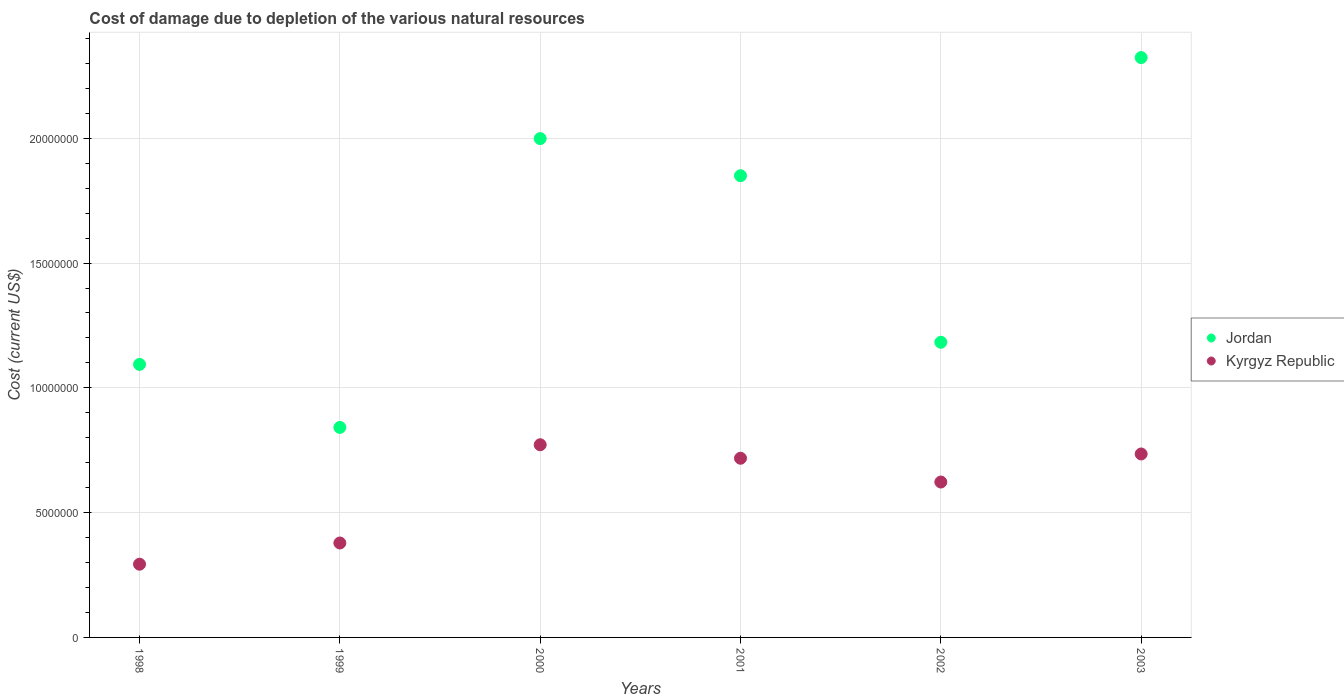How many different coloured dotlines are there?
Give a very brief answer. 2. What is the cost of damage caused due to the depletion of various natural resources in Jordan in 1998?
Give a very brief answer. 1.09e+07. Across all years, what is the maximum cost of damage caused due to the depletion of various natural resources in Kyrgyz Republic?
Ensure brevity in your answer.  7.72e+06. Across all years, what is the minimum cost of damage caused due to the depletion of various natural resources in Jordan?
Provide a succinct answer. 8.41e+06. In which year was the cost of damage caused due to the depletion of various natural resources in Kyrgyz Republic maximum?
Offer a terse response. 2000. What is the total cost of damage caused due to the depletion of various natural resources in Jordan in the graph?
Provide a succinct answer. 9.29e+07. What is the difference between the cost of damage caused due to the depletion of various natural resources in Jordan in 1998 and that in 2002?
Provide a short and direct response. -8.87e+05. What is the difference between the cost of damage caused due to the depletion of various natural resources in Jordan in 2002 and the cost of damage caused due to the depletion of various natural resources in Kyrgyz Republic in 1999?
Give a very brief answer. 8.04e+06. What is the average cost of damage caused due to the depletion of various natural resources in Kyrgyz Republic per year?
Your answer should be compact. 5.87e+06. In the year 2000, what is the difference between the cost of damage caused due to the depletion of various natural resources in Jordan and cost of damage caused due to the depletion of various natural resources in Kyrgyz Republic?
Your response must be concise. 1.23e+07. What is the ratio of the cost of damage caused due to the depletion of various natural resources in Kyrgyz Republic in 1999 to that in 2001?
Offer a very short reply. 0.53. Is the cost of damage caused due to the depletion of various natural resources in Kyrgyz Republic in 2000 less than that in 2003?
Provide a succinct answer. No. What is the difference between the highest and the second highest cost of damage caused due to the depletion of various natural resources in Jordan?
Make the answer very short. 3.25e+06. What is the difference between the highest and the lowest cost of damage caused due to the depletion of various natural resources in Jordan?
Keep it short and to the point. 1.48e+07. In how many years, is the cost of damage caused due to the depletion of various natural resources in Kyrgyz Republic greater than the average cost of damage caused due to the depletion of various natural resources in Kyrgyz Republic taken over all years?
Offer a terse response. 4. Is the sum of the cost of damage caused due to the depletion of various natural resources in Jordan in 2000 and 2003 greater than the maximum cost of damage caused due to the depletion of various natural resources in Kyrgyz Republic across all years?
Provide a short and direct response. Yes. Does the cost of damage caused due to the depletion of various natural resources in Kyrgyz Republic monotonically increase over the years?
Make the answer very short. No. Is the cost of damage caused due to the depletion of various natural resources in Jordan strictly less than the cost of damage caused due to the depletion of various natural resources in Kyrgyz Republic over the years?
Ensure brevity in your answer.  No. How many dotlines are there?
Make the answer very short. 2. How many years are there in the graph?
Provide a succinct answer. 6. What is the difference between two consecutive major ticks on the Y-axis?
Make the answer very short. 5.00e+06. Are the values on the major ticks of Y-axis written in scientific E-notation?
Offer a terse response. No. How are the legend labels stacked?
Provide a short and direct response. Vertical. What is the title of the graph?
Provide a short and direct response. Cost of damage due to depletion of the various natural resources. What is the label or title of the X-axis?
Offer a terse response. Years. What is the label or title of the Y-axis?
Your response must be concise. Cost (current US$). What is the Cost (current US$) in Jordan in 1998?
Your answer should be very brief. 1.09e+07. What is the Cost (current US$) in Kyrgyz Republic in 1998?
Your answer should be very brief. 2.93e+06. What is the Cost (current US$) of Jordan in 1999?
Keep it short and to the point. 8.41e+06. What is the Cost (current US$) of Kyrgyz Republic in 1999?
Your answer should be compact. 3.78e+06. What is the Cost (current US$) in Jordan in 2000?
Offer a terse response. 2.00e+07. What is the Cost (current US$) in Kyrgyz Republic in 2000?
Your answer should be compact. 7.72e+06. What is the Cost (current US$) in Jordan in 2001?
Offer a terse response. 1.85e+07. What is the Cost (current US$) of Kyrgyz Republic in 2001?
Keep it short and to the point. 7.18e+06. What is the Cost (current US$) of Jordan in 2002?
Make the answer very short. 1.18e+07. What is the Cost (current US$) in Kyrgyz Republic in 2002?
Your answer should be very brief. 6.23e+06. What is the Cost (current US$) of Jordan in 2003?
Your response must be concise. 2.32e+07. What is the Cost (current US$) in Kyrgyz Republic in 2003?
Keep it short and to the point. 7.35e+06. Across all years, what is the maximum Cost (current US$) of Jordan?
Offer a very short reply. 2.32e+07. Across all years, what is the maximum Cost (current US$) in Kyrgyz Republic?
Your answer should be very brief. 7.72e+06. Across all years, what is the minimum Cost (current US$) of Jordan?
Your answer should be compact. 8.41e+06. Across all years, what is the minimum Cost (current US$) of Kyrgyz Republic?
Your answer should be compact. 2.93e+06. What is the total Cost (current US$) in Jordan in the graph?
Your answer should be very brief. 9.29e+07. What is the total Cost (current US$) in Kyrgyz Republic in the graph?
Provide a short and direct response. 3.52e+07. What is the difference between the Cost (current US$) in Jordan in 1998 and that in 1999?
Offer a very short reply. 2.53e+06. What is the difference between the Cost (current US$) in Kyrgyz Republic in 1998 and that in 1999?
Make the answer very short. -8.50e+05. What is the difference between the Cost (current US$) of Jordan in 1998 and that in 2000?
Your answer should be compact. -9.05e+06. What is the difference between the Cost (current US$) of Kyrgyz Republic in 1998 and that in 2000?
Give a very brief answer. -4.79e+06. What is the difference between the Cost (current US$) of Jordan in 1998 and that in 2001?
Offer a terse response. -7.56e+06. What is the difference between the Cost (current US$) in Kyrgyz Republic in 1998 and that in 2001?
Ensure brevity in your answer.  -4.25e+06. What is the difference between the Cost (current US$) of Jordan in 1998 and that in 2002?
Ensure brevity in your answer.  -8.87e+05. What is the difference between the Cost (current US$) of Kyrgyz Republic in 1998 and that in 2002?
Keep it short and to the point. -3.29e+06. What is the difference between the Cost (current US$) in Jordan in 1998 and that in 2003?
Ensure brevity in your answer.  -1.23e+07. What is the difference between the Cost (current US$) in Kyrgyz Republic in 1998 and that in 2003?
Your answer should be compact. -4.42e+06. What is the difference between the Cost (current US$) of Jordan in 1999 and that in 2000?
Ensure brevity in your answer.  -1.16e+07. What is the difference between the Cost (current US$) of Kyrgyz Republic in 1999 and that in 2000?
Ensure brevity in your answer.  -3.94e+06. What is the difference between the Cost (current US$) in Jordan in 1999 and that in 2001?
Your answer should be compact. -1.01e+07. What is the difference between the Cost (current US$) of Kyrgyz Republic in 1999 and that in 2001?
Your answer should be very brief. -3.40e+06. What is the difference between the Cost (current US$) of Jordan in 1999 and that in 2002?
Offer a very short reply. -3.41e+06. What is the difference between the Cost (current US$) of Kyrgyz Republic in 1999 and that in 2002?
Your answer should be very brief. -2.44e+06. What is the difference between the Cost (current US$) of Jordan in 1999 and that in 2003?
Offer a terse response. -1.48e+07. What is the difference between the Cost (current US$) of Kyrgyz Republic in 1999 and that in 2003?
Provide a short and direct response. -3.57e+06. What is the difference between the Cost (current US$) in Jordan in 2000 and that in 2001?
Keep it short and to the point. 1.49e+06. What is the difference between the Cost (current US$) in Kyrgyz Republic in 2000 and that in 2001?
Your response must be concise. 5.40e+05. What is the difference between the Cost (current US$) of Jordan in 2000 and that in 2002?
Give a very brief answer. 8.16e+06. What is the difference between the Cost (current US$) of Kyrgyz Republic in 2000 and that in 2002?
Keep it short and to the point. 1.49e+06. What is the difference between the Cost (current US$) of Jordan in 2000 and that in 2003?
Offer a very short reply. -3.25e+06. What is the difference between the Cost (current US$) of Kyrgyz Republic in 2000 and that in 2003?
Make the answer very short. 3.69e+05. What is the difference between the Cost (current US$) in Jordan in 2001 and that in 2002?
Make the answer very short. 6.67e+06. What is the difference between the Cost (current US$) of Kyrgyz Republic in 2001 and that in 2002?
Offer a terse response. 9.53e+05. What is the difference between the Cost (current US$) in Jordan in 2001 and that in 2003?
Your answer should be very brief. -4.73e+06. What is the difference between the Cost (current US$) in Kyrgyz Republic in 2001 and that in 2003?
Your response must be concise. -1.71e+05. What is the difference between the Cost (current US$) in Jordan in 2002 and that in 2003?
Provide a short and direct response. -1.14e+07. What is the difference between the Cost (current US$) in Kyrgyz Republic in 2002 and that in 2003?
Provide a short and direct response. -1.12e+06. What is the difference between the Cost (current US$) of Jordan in 1998 and the Cost (current US$) of Kyrgyz Republic in 1999?
Make the answer very short. 7.16e+06. What is the difference between the Cost (current US$) of Jordan in 1998 and the Cost (current US$) of Kyrgyz Republic in 2000?
Ensure brevity in your answer.  3.22e+06. What is the difference between the Cost (current US$) of Jordan in 1998 and the Cost (current US$) of Kyrgyz Republic in 2001?
Provide a succinct answer. 3.76e+06. What is the difference between the Cost (current US$) of Jordan in 1998 and the Cost (current US$) of Kyrgyz Republic in 2002?
Offer a very short reply. 4.71e+06. What is the difference between the Cost (current US$) of Jordan in 1998 and the Cost (current US$) of Kyrgyz Republic in 2003?
Your response must be concise. 3.59e+06. What is the difference between the Cost (current US$) of Jordan in 1999 and the Cost (current US$) of Kyrgyz Republic in 2000?
Make the answer very short. 6.95e+05. What is the difference between the Cost (current US$) in Jordan in 1999 and the Cost (current US$) in Kyrgyz Republic in 2001?
Provide a succinct answer. 1.24e+06. What is the difference between the Cost (current US$) of Jordan in 1999 and the Cost (current US$) of Kyrgyz Republic in 2002?
Provide a short and direct response. 2.19e+06. What is the difference between the Cost (current US$) of Jordan in 1999 and the Cost (current US$) of Kyrgyz Republic in 2003?
Give a very brief answer. 1.06e+06. What is the difference between the Cost (current US$) of Jordan in 2000 and the Cost (current US$) of Kyrgyz Republic in 2001?
Ensure brevity in your answer.  1.28e+07. What is the difference between the Cost (current US$) in Jordan in 2000 and the Cost (current US$) in Kyrgyz Republic in 2002?
Provide a short and direct response. 1.38e+07. What is the difference between the Cost (current US$) in Jordan in 2000 and the Cost (current US$) in Kyrgyz Republic in 2003?
Your answer should be very brief. 1.26e+07. What is the difference between the Cost (current US$) in Jordan in 2001 and the Cost (current US$) in Kyrgyz Republic in 2002?
Offer a very short reply. 1.23e+07. What is the difference between the Cost (current US$) in Jordan in 2001 and the Cost (current US$) in Kyrgyz Republic in 2003?
Offer a terse response. 1.11e+07. What is the difference between the Cost (current US$) in Jordan in 2002 and the Cost (current US$) in Kyrgyz Republic in 2003?
Your answer should be very brief. 4.48e+06. What is the average Cost (current US$) of Jordan per year?
Your answer should be very brief. 1.55e+07. What is the average Cost (current US$) in Kyrgyz Republic per year?
Give a very brief answer. 5.87e+06. In the year 1998, what is the difference between the Cost (current US$) of Jordan and Cost (current US$) of Kyrgyz Republic?
Ensure brevity in your answer.  8.01e+06. In the year 1999, what is the difference between the Cost (current US$) of Jordan and Cost (current US$) of Kyrgyz Republic?
Provide a short and direct response. 4.63e+06. In the year 2000, what is the difference between the Cost (current US$) in Jordan and Cost (current US$) in Kyrgyz Republic?
Provide a short and direct response. 1.23e+07. In the year 2001, what is the difference between the Cost (current US$) of Jordan and Cost (current US$) of Kyrgyz Republic?
Your answer should be compact. 1.13e+07. In the year 2002, what is the difference between the Cost (current US$) of Jordan and Cost (current US$) of Kyrgyz Republic?
Offer a terse response. 5.60e+06. In the year 2003, what is the difference between the Cost (current US$) of Jordan and Cost (current US$) of Kyrgyz Republic?
Offer a terse response. 1.59e+07. What is the ratio of the Cost (current US$) of Jordan in 1998 to that in 1999?
Make the answer very short. 1.3. What is the ratio of the Cost (current US$) of Kyrgyz Republic in 1998 to that in 1999?
Make the answer very short. 0.78. What is the ratio of the Cost (current US$) of Jordan in 1998 to that in 2000?
Keep it short and to the point. 0.55. What is the ratio of the Cost (current US$) of Kyrgyz Republic in 1998 to that in 2000?
Your answer should be very brief. 0.38. What is the ratio of the Cost (current US$) of Jordan in 1998 to that in 2001?
Give a very brief answer. 0.59. What is the ratio of the Cost (current US$) in Kyrgyz Republic in 1998 to that in 2001?
Make the answer very short. 0.41. What is the ratio of the Cost (current US$) in Jordan in 1998 to that in 2002?
Your response must be concise. 0.93. What is the ratio of the Cost (current US$) in Kyrgyz Republic in 1998 to that in 2002?
Make the answer very short. 0.47. What is the ratio of the Cost (current US$) of Jordan in 1998 to that in 2003?
Your response must be concise. 0.47. What is the ratio of the Cost (current US$) of Kyrgyz Republic in 1998 to that in 2003?
Keep it short and to the point. 0.4. What is the ratio of the Cost (current US$) of Jordan in 1999 to that in 2000?
Give a very brief answer. 0.42. What is the ratio of the Cost (current US$) of Kyrgyz Republic in 1999 to that in 2000?
Your answer should be compact. 0.49. What is the ratio of the Cost (current US$) of Jordan in 1999 to that in 2001?
Ensure brevity in your answer.  0.45. What is the ratio of the Cost (current US$) in Kyrgyz Republic in 1999 to that in 2001?
Ensure brevity in your answer.  0.53. What is the ratio of the Cost (current US$) in Jordan in 1999 to that in 2002?
Give a very brief answer. 0.71. What is the ratio of the Cost (current US$) in Kyrgyz Republic in 1999 to that in 2002?
Your answer should be compact. 0.61. What is the ratio of the Cost (current US$) in Jordan in 1999 to that in 2003?
Your answer should be very brief. 0.36. What is the ratio of the Cost (current US$) in Kyrgyz Republic in 1999 to that in 2003?
Offer a very short reply. 0.51. What is the ratio of the Cost (current US$) in Jordan in 2000 to that in 2001?
Offer a very short reply. 1.08. What is the ratio of the Cost (current US$) in Kyrgyz Republic in 2000 to that in 2001?
Provide a short and direct response. 1.08. What is the ratio of the Cost (current US$) in Jordan in 2000 to that in 2002?
Your answer should be compact. 1.69. What is the ratio of the Cost (current US$) of Kyrgyz Republic in 2000 to that in 2002?
Ensure brevity in your answer.  1.24. What is the ratio of the Cost (current US$) of Jordan in 2000 to that in 2003?
Provide a short and direct response. 0.86. What is the ratio of the Cost (current US$) in Kyrgyz Republic in 2000 to that in 2003?
Make the answer very short. 1.05. What is the ratio of the Cost (current US$) in Jordan in 2001 to that in 2002?
Offer a very short reply. 1.56. What is the ratio of the Cost (current US$) of Kyrgyz Republic in 2001 to that in 2002?
Your answer should be very brief. 1.15. What is the ratio of the Cost (current US$) of Jordan in 2001 to that in 2003?
Offer a very short reply. 0.8. What is the ratio of the Cost (current US$) of Kyrgyz Republic in 2001 to that in 2003?
Provide a succinct answer. 0.98. What is the ratio of the Cost (current US$) in Jordan in 2002 to that in 2003?
Make the answer very short. 0.51. What is the ratio of the Cost (current US$) in Kyrgyz Republic in 2002 to that in 2003?
Provide a succinct answer. 0.85. What is the difference between the highest and the second highest Cost (current US$) of Jordan?
Keep it short and to the point. 3.25e+06. What is the difference between the highest and the second highest Cost (current US$) in Kyrgyz Republic?
Provide a succinct answer. 3.69e+05. What is the difference between the highest and the lowest Cost (current US$) of Jordan?
Ensure brevity in your answer.  1.48e+07. What is the difference between the highest and the lowest Cost (current US$) in Kyrgyz Republic?
Keep it short and to the point. 4.79e+06. 